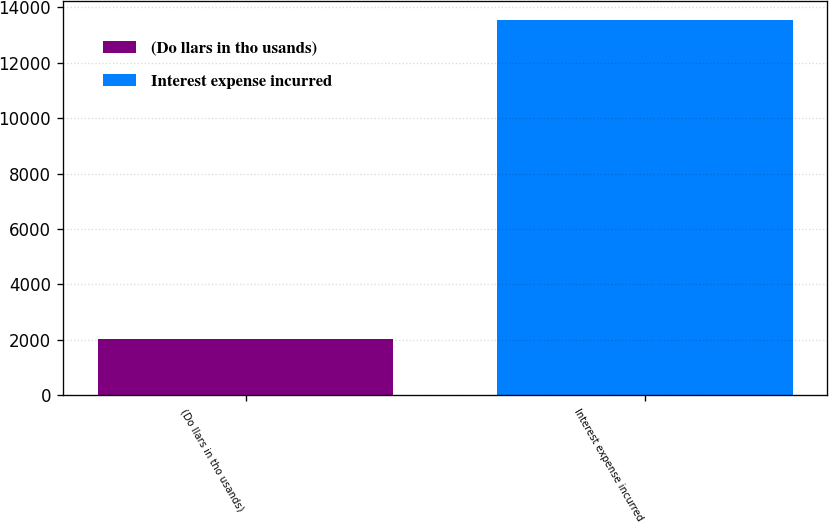<chart> <loc_0><loc_0><loc_500><loc_500><bar_chart><fcel>(Do llars in tho usands)<fcel>Interest expense incurred<nl><fcel>2011<fcel>13546<nl></chart> 